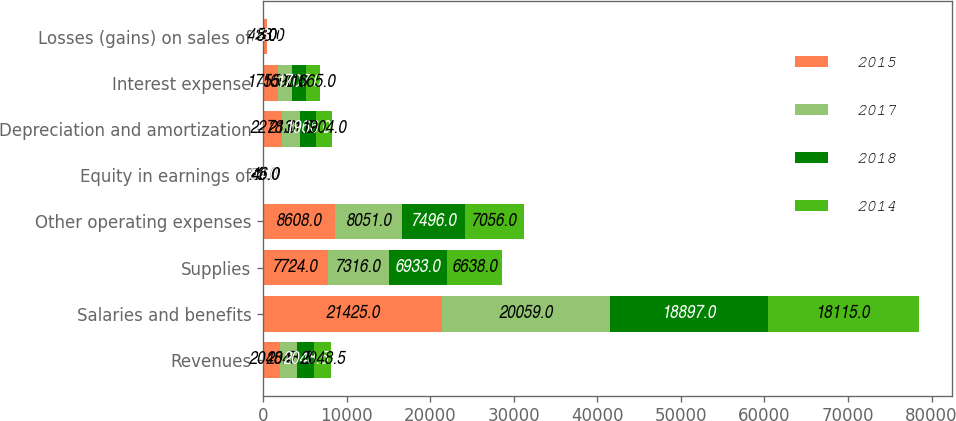Convert chart. <chart><loc_0><loc_0><loc_500><loc_500><stacked_bar_chart><ecel><fcel>Revenues<fcel>Salaries and benefits<fcel>Supplies<fcel>Other operating expenses<fcel>Equity in earnings of<fcel>Depreciation and amortization<fcel>Interest expense<fcel>Losses (gains) on sales of<nl><fcel>2015<fcel>2048.5<fcel>21425<fcel>7724<fcel>8608<fcel>29<fcel>2278<fcel>1755<fcel>428<nl><fcel>2017<fcel>2048.5<fcel>20059<fcel>7316<fcel>8051<fcel>45<fcel>2131<fcel>1690<fcel>8<nl><fcel>2018<fcel>2048.5<fcel>18897<fcel>6933<fcel>7496<fcel>54<fcel>1966<fcel>1707<fcel>23<nl><fcel>2014<fcel>2048.5<fcel>18115<fcel>6638<fcel>7056<fcel>46<fcel>1904<fcel>1665<fcel>5<nl></chart> 